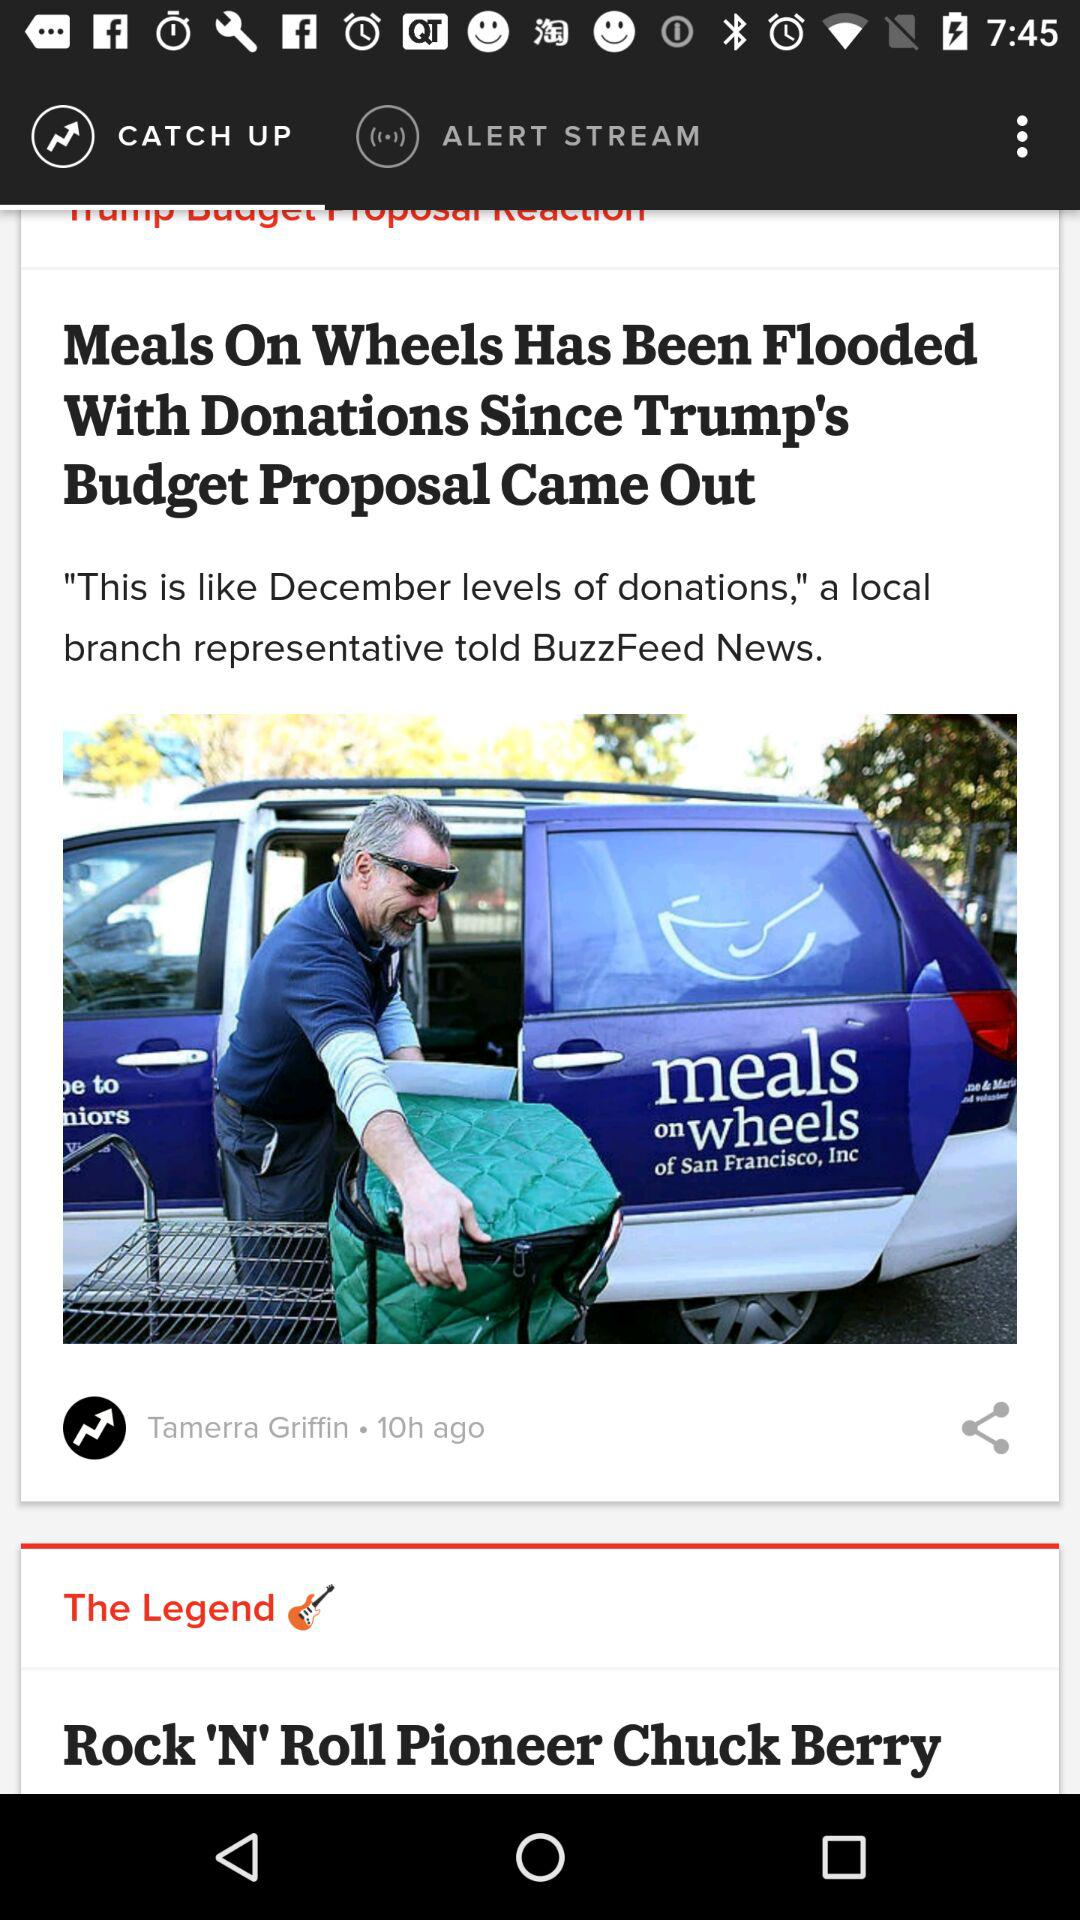Which tab is currently selected? The currently selected tab is "CATCH UP". 